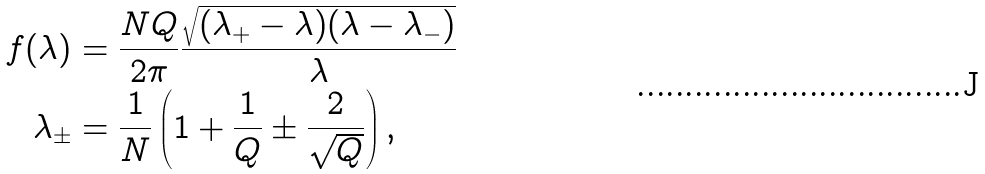<formula> <loc_0><loc_0><loc_500><loc_500>f ( \lambda ) & = \frac { N Q } { 2 \pi } \frac { \sqrt { ( \lambda _ { + } - \lambda ) ( \lambda - \lambda _ { - } ) } } { \lambda } \\ \lambda _ { \pm } & = \frac { 1 } { N } \left ( 1 + \frac { 1 } { Q } \pm \frac { 2 } { \sqrt { Q } } \right ) ,</formula> 